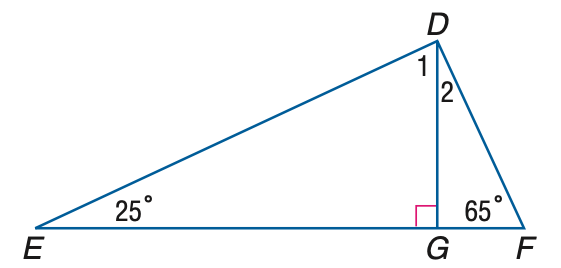Answer the mathemtical geometry problem and directly provide the correct option letter.
Question: Find the measure of \angle 2.
Choices: A: 25 B: 35 C: 45 D: 55 A 